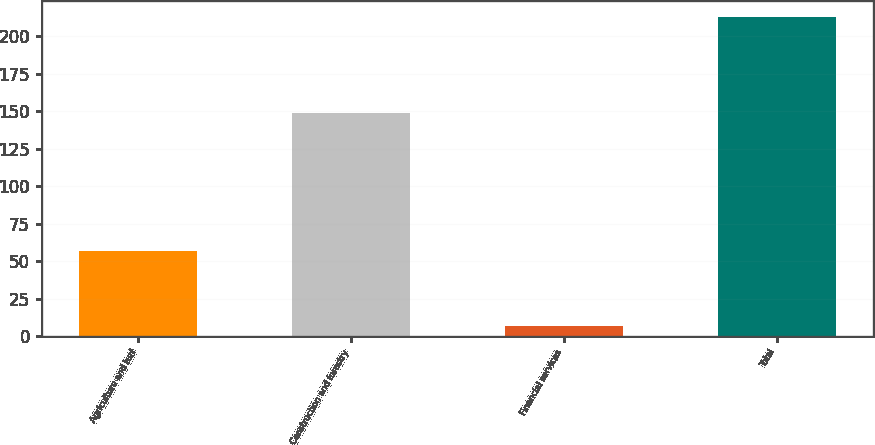Convert chart. <chart><loc_0><loc_0><loc_500><loc_500><bar_chart><fcel>Agriculture and turf<fcel>Construction and forestry<fcel>Financial services<fcel>Total<nl><fcel>57<fcel>149<fcel>7<fcel>213<nl></chart> 